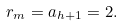Convert formula to latex. <formula><loc_0><loc_0><loc_500><loc_500>r _ { m } = a _ { h + 1 } = 2 .</formula> 